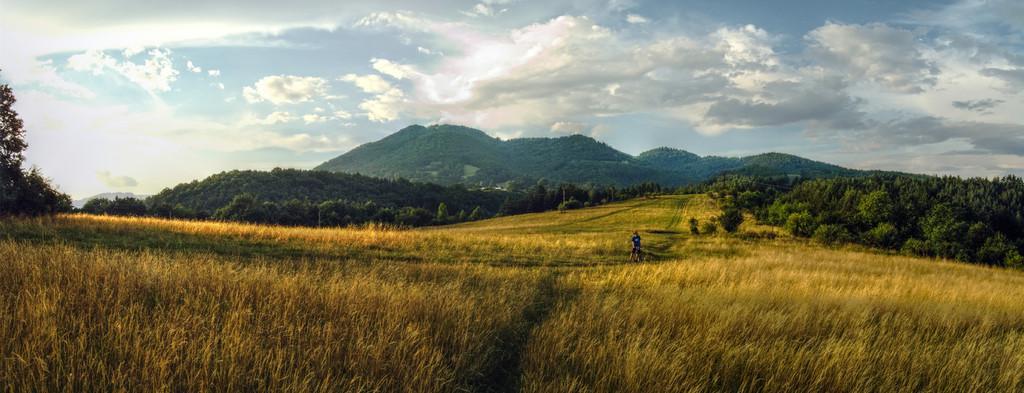Can you describe this image briefly? In this image I can see few plants which are yellow, brown and green in color, a person standing and few trees which are green in color. In the background I can see few mountains, few trees on the mountains and the sky. 